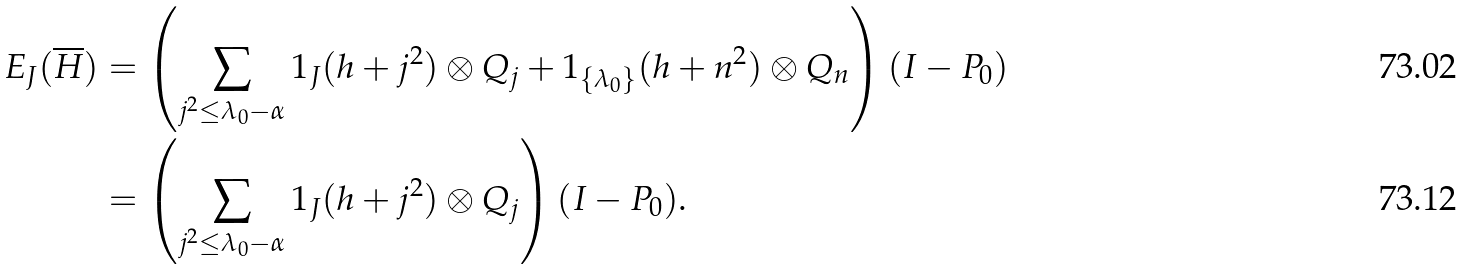Convert formula to latex. <formula><loc_0><loc_0><loc_500><loc_500>E _ { J } ( \overline { H } ) & = \left ( \sum _ { j ^ { 2 } \leq \lambda _ { 0 } - \alpha } 1 _ { J } ( h + j ^ { 2 } ) \otimes Q _ { j } + 1 _ { \{ \lambda _ { 0 } \} } ( h + n ^ { 2 } ) \otimes Q _ { n } \right ) ( I - P _ { 0 } ) \\ & = \left ( \sum _ { j ^ { 2 } \leq \lambda _ { 0 } - \alpha } 1 _ { J } ( h + j ^ { 2 } ) \otimes Q _ { j } \right ) ( I - P _ { 0 } ) .</formula> 